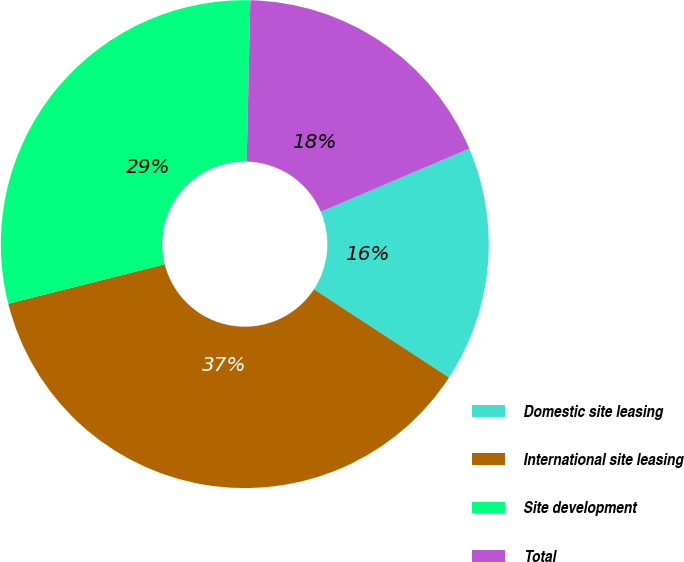Convert chart to OTSL. <chart><loc_0><loc_0><loc_500><loc_500><pie_chart><fcel>Domestic site leasing<fcel>International site leasing<fcel>Site development<fcel>Total<nl><fcel>15.61%<fcel>36.87%<fcel>29.29%<fcel>18.24%<nl></chart> 